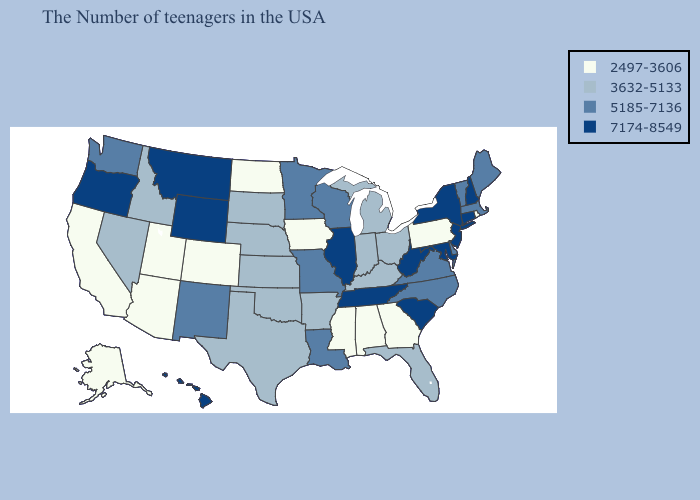Does Alabama have a lower value than Idaho?
Answer briefly. Yes. Does Maryland have the highest value in the USA?
Concise answer only. Yes. Name the states that have a value in the range 2497-3606?
Be succinct. Rhode Island, Pennsylvania, Georgia, Alabama, Mississippi, Iowa, North Dakota, Colorado, Utah, Arizona, California, Alaska. Among the states that border North Carolina , which have the highest value?
Write a very short answer. South Carolina, Tennessee. What is the value of Mississippi?
Write a very short answer. 2497-3606. Is the legend a continuous bar?
Give a very brief answer. No. What is the highest value in the USA?
Concise answer only. 7174-8549. Name the states that have a value in the range 2497-3606?
Short answer required. Rhode Island, Pennsylvania, Georgia, Alabama, Mississippi, Iowa, North Dakota, Colorado, Utah, Arizona, California, Alaska. Among the states that border Texas , does Louisiana have the highest value?
Concise answer only. Yes. Name the states that have a value in the range 2497-3606?
Be succinct. Rhode Island, Pennsylvania, Georgia, Alabama, Mississippi, Iowa, North Dakota, Colorado, Utah, Arizona, California, Alaska. Among the states that border Vermont , does Massachusetts have the lowest value?
Write a very short answer. Yes. Name the states that have a value in the range 7174-8549?
Write a very short answer. New Hampshire, Connecticut, New York, New Jersey, Maryland, South Carolina, West Virginia, Tennessee, Illinois, Wyoming, Montana, Oregon, Hawaii. What is the value of Florida?
Short answer required. 3632-5133. Name the states that have a value in the range 2497-3606?
Be succinct. Rhode Island, Pennsylvania, Georgia, Alabama, Mississippi, Iowa, North Dakota, Colorado, Utah, Arizona, California, Alaska. 